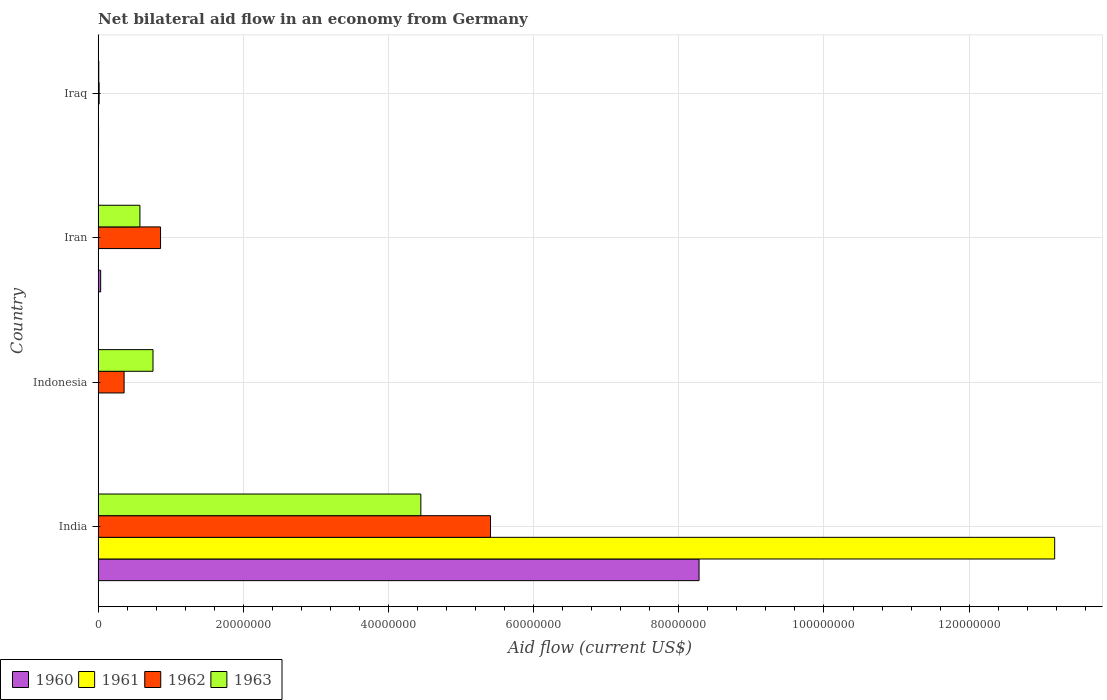How many bars are there on the 4th tick from the top?
Give a very brief answer. 4. How many bars are there on the 1st tick from the bottom?
Offer a very short reply. 4. In how many cases, is the number of bars for a given country not equal to the number of legend labels?
Your answer should be very brief. 1. Across all countries, what is the maximum net bilateral aid flow in 1963?
Your response must be concise. 4.45e+07. What is the total net bilateral aid flow in 1963 in the graph?
Your answer should be compact. 5.79e+07. What is the difference between the net bilateral aid flow in 1962 in Iran and that in Iraq?
Provide a succinct answer. 8.46e+06. What is the difference between the net bilateral aid flow in 1960 in India and the net bilateral aid flow in 1963 in Indonesia?
Give a very brief answer. 7.52e+07. What is the average net bilateral aid flow in 1963 per country?
Provide a succinct answer. 1.45e+07. What is the difference between the net bilateral aid flow in 1962 and net bilateral aid flow in 1960 in India?
Make the answer very short. -2.87e+07. What is the ratio of the net bilateral aid flow in 1963 in India to that in Indonesia?
Make the answer very short. 5.88. Is the net bilateral aid flow in 1962 in Indonesia less than that in Iraq?
Make the answer very short. No. Is the difference between the net bilateral aid flow in 1962 in Iran and Iraq greater than the difference between the net bilateral aid flow in 1960 in Iran and Iraq?
Your response must be concise. Yes. What is the difference between the highest and the second highest net bilateral aid flow in 1963?
Provide a short and direct response. 3.69e+07. What is the difference between the highest and the lowest net bilateral aid flow in 1960?
Make the answer very short. 8.28e+07. Is the sum of the net bilateral aid flow in 1960 in India and Iran greater than the maximum net bilateral aid flow in 1963 across all countries?
Give a very brief answer. Yes. Are all the bars in the graph horizontal?
Your answer should be compact. Yes. What is the difference between two consecutive major ticks on the X-axis?
Your answer should be compact. 2.00e+07. Does the graph contain grids?
Offer a terse response. Yes. Where does the legend appear in the graph?
Make the answer very short. Bottom left. How are the legend labels stacked?
Ensure brevity in your answer.  Horizontal. What is the title of the graph?
Your response must be concise. Net bilateral aid flow in an economy from Germany. Does "1966" appear as one of the legend labels in the graph?
Provide a succinct answer. No. What is the label or title of the Y-axis?
Ensure brevity in your answer.  Country. What is the Aid flow (current US$) of 1960 in India?
Ensure brevity in your answer.  8.28e+07. What is the Aid flow (current US$) of 1961 in India?
Offer a terse response. 1.32e+08. What is the Aid flow (current US$) in 1962 in India?
Provide a short and direct response. 5.41e+07. What is the Aid flow (current US$) of 1963 in India?
Give a very brief answer. 4.45e+07. What is the Aid flow (current US$) in 1960 in Indonesia?
Provide a succinct answer. 0. What is the Aid flow (current US$) in 1961 in Indonesia?
Provide a short and direct response. 0. What is the Aid flow (current US$) in 1962 in Indonesia?
Make the answer very short. 3.58e+06. What is the Aid flow (current US$) of 1963 in Indonesia?
Offer a very short reply. 7.56e+06. What is the Aid flow (current US$) of 1960 in Iran?
Keep it short and to the point. 3.50e+05. What is the Aid flow (current US$) in 1961 in Iran?
Make the answer very short. 3.00e+04. What is the Aid flow (current US$) of 1962 in Iran?
Provide a short and direct response. 8.60e+06. What is the Aid flow (current US$) of 1963 in Iran?
Ensure brevity in your answer.  5.76e+06. What is the Aid flow (current US$) in 1960 in Iraq?
Give a very brief answer. 6.00e+04. What is the Aid flow (current US$) of 1961 in Iraq?
Provide a succinct answer. 2.00e+04. What is the Aid flow (current US$) in 1962 in Iraq?
Your response must be concise. 1.40e+05. Across all countries, what is the maximum Aid flow (current US$) of 1960?
Give a very brief answer. 8.28e+07. Across all countries, what is the maximum Aid flow (current US$) of 1961?
Ensure brevity in your answer.  1.32e+08. Across all countries, what is the maximum Aid flow (current US$) in 1962?
Offer a very short reply. 5.41e+07. Across all countries, what is the maximum Aid flow (current US$) of 1963?
Your answer should be very brief. 4.45e+07. Across all countries, what is the minimum Aid flow (current US$) in 1960?
Make the answer very short. 0. Across all countries, what is the minimum Aid flow (current US$) in 1963?
Keep it short and to the point. 9.00e+04. What is the total Aid flow (current US$) in 1960 in the graph?
Provide a succinct answer. 8.32e+07. What is the total Aid flow (current US$) of 1961 in the graph?
Your answer should be compact. 1.32e+08. What is the total Aid flow (current US$) of 1962 in the graph?
Provide a succinct answer. 6.64e+07. What is the total Aid flow (current US$) in 1963 in the graph?
Provide a succinct answer. 5.79e+07. What is the difference between the Aid flow (current US$) of 1962 in India and that in Indonesia?
Your answer should be very brief. 5.05e+07. What is the difference between the Aid flow (current US$) of 1963 in India and that in Indonesia?
Provide a short and direct response. 3.69e+07. What is the difference between the Aid flow (current US$) of 1960 in India and that in Iran?
Give a very brief answer. 8.24e+07. What is the difference between the Aid flow (current US$) of 1961 in India and that in Iran?
Your answer should be very brief. 1.32e+08. What is the difference between the Aid flow (current US$) of 1962 in India and that in Iran?
Give a very brief answer. 4.55e+07. What is the difference between the Aid flow (current US$) in 1963 in India and that in Iran?
Ensure brevity in your answer.  3.87e+07. What is the difference between the Aid flow (current US$) of 1960 in India and that in Iraq?
Ensure brevity in your answer.  8.27e+07. What is the difference between the Aid flow (current US$) in 1961 in India and that in Iraq?
Your answer should be very brief. 1.32e+08. What is the difference between the Aid flow (current US$) of 1962 in India and that in Iraq?
Give a very brief answer. 5.39e+07. What is the difference between the Aid flow (current US$) of 1963 in India and that in Iraq?
Provide a succinct answer. 4.44e+07. What is the difference between the Aid flow (current US$) in 1962 in Indonesia and that in Iran?
Make the answer very short. -5.02e+06. What is the difference between the Aid flow (current US$) in 1963 in Indonesia and that in Iran?
Keep it short and to the point. 1.80e+06. What is the difference between the Aid flow (current US$) of 1962 in Indonesia and that in Iraq?
Provide a succinct answer. 3.44e+06. What is the difference between the Aid flow (current US$) of 1963 in Indonesia and that in Iraq?
Your response must be concise. 7.47e+06. What is the difference between the Aid flow (current US$) in 1961 in Iran and that in Iraq?
Offer a very short reply. 10000. What is the difference between the Aid flow (current US$) in 1962 in Iran and that in Iraq?
Ensure brevity in your answer.  8.46e+06. What is the difference between the Aid flow (current US$) of 1963 in Iran and that in Iraq?
Provide a succinct answer. 5.67e+06. What is the difference between the Aid flow (current US$) in 1960 in India and the Aid flow (current US$) in 1962 in Indonesia?
Offer a terse response. 7.92e+07. What is the difference between the Aid flow (current US$) in 1960 in India and the Aid flow (current US$) in 1963 in Indonesia?
Make the answer very short. 7.52e+07. What is the difference between the Aid flow (current US$) of 1961 in India and the Aid flow (current US$) of 1962 in Indonesia?
Your answer should be compact. 1.28e+08. What is the difference between the Aid flow (current US$) of 1961 in India and the Aid flow (current US$) of 1963 in Indonesia?
Your answer should be compact. 1.24e+08. What is the difference between the Aid flow (current US$) of 1962 in India and the Aid flow (current US$) of 1963 in Indonesia?
Offer a terse response. 4.65e+07. What is the difference between the Aid flow (current US$) of 1960 in India and the Aid flow (current US$) of 1961 in Iran?
Provide a succinct answer. 8.28e+07. What is the difference between the Aid flow (current US$) of 1960 in India and the Aid flow (current US$) of 1962 in Iran?
Your answer should be compact. 7.42e+07. What is the difference between the Aid flow (current US$) of 1960 in India and the Aid flow (current US$) of 1963 in Iran?
Provide a short and direct response. 7.70e+07. What is the difference between the Aid flow (current US$) of 1961 in India and the Aid flow (current US$) of 1962 in Iran?
Offer a terse response. 1.23e+08. What is the difference between the Aid flow (current US$) of 1961 in India and the Aid flow (current US$) of 1963 in Iran?
Provide a succinct answer. 1.26e+08. What is the difference between the Aid flow (current US$) of 1962 in India and the Aid flow (current US$) of 1963 in Iran?
Offer a terse response. 4.83e+07. What is the difference between the Aid flow (current US$) in 1960 in India and the Aid flow (current US$) in 1961 in Iraq?
Your answer should be compact. 8.28e+07. What is the difference between the Aid flow (current US$) in 1960 in India and the Aid flow (current US$) in 1962 in Iraq?
Give a very brief answer. 8.26e+07. What is the difference between the Aid flow (current US$) in 1960 in India and the Aid flow (current US$) in 1963 in Iraq?
Offer a terse response. 8.27e+07. What is the difference between the Aid flow (current US$) of 1961 in India and the Aid flow (current US$) of 1962 in Iraq?
Give a very brief answer. 1.32e+08. What is the difference between the Aid flow (current US$) in 1961 in India and the Aid flow (current US$) in 1963 in Iraq?
Make the answer very short. 1.32e+08. What is the difference between the Aid flow (current US$) of 1962 in India and the Aid flow (current US$) of 1963 in Iraq?
Keep it short and to the point. 5.40e+07. What is the difference between the Aid flow (current US$) in 1962 in Indonesia and the Aid flow (current US$) in 1963 in Iran?
Offer a terse response. -2.18e+06. What is the difference between the Aid flow (current US$) in 1962 in Indonesia and the Aid flow (current US$) in 1963 in Iraq?
Ensure brevity in your answer.  3.49e+06. What is the difference between the Aid flow (current US$) of 1960 in Iran and the Aid flow (current US$) of 1961 in Iraq?
Provide a succinct answer. 3.30e+05. What is the difference between the Aid flow (current US$) in 1960 in Iran and the Aid flow (current US$) in 1962 in Iraq?
Your answer should be compact. 2.10e+05. What is the difference between the Aid flow (current US$) of 1960 in Iran and the Aid flow (current US$) of 1963 in Iraq?
Make the answer very short. 2.60e+05. What is the difference between the Aid flow (current US$) of 1961 in Iran and the Aid flow (current US$) of 1962 in Iraq?
Your response must be concise. -1.10e+05. What is the difference between the Aid flow (current US$) of 1961 in Iran and the Aid flow (current US$) of 1963 in Iraq?
Ensure brevity in your answer.  -6.00e+04. What is the difference between the Aid flow (current US$) of 1962 in Iran and the Aid flow (current US$) of 1963 in Iraq?
Your answer should be very brief. 8.51e+06. What is the average Aid flow (current US$) in 1960 per country?
Make the answer very short. 2.08e+07. What is the average Aid flow (current US$) of 1961 per country?
Offer a terse response. 3.30e+07. What is the average Aid flow (current US$) of 1962 per country?
Provide a short and direct response. 1.66e+07. What is the average Aid flow (current US$) of 1963 per country?
Offer a very short reply. 1.45e+07. What is the difference between the Aid flow (current US$) in 1960 and Aid flow (current US$) in 1961 in India?
Your answer should be very brief. -4.90e+07. What is the difference between the Aid flow (current US$) in 1960 and Aid flow (current US$) in 1962 in India?
Give a very brief answer. 2.87e+07. What is the difference between the Aid flow (current US$) in 1960 and Aid flow (current US$) in 1963 in India?
Give a very brief answer. 3.83e+07. What is the difference between the Aid flow (current US$) in 1961 and Aid flow (current US$) in 1962 in India?
Offer a terse response. 7.77e+07. What is the difference between the Aid flow (current US$) of 1961 and Aid flow (current US$) of 1963 in India?
Keep it short and to the point. 8.73e+07. What is the difference between the Aid flow (current US$) of 1962 and Aid flow (current US$) of 1963 in India?
Your answer should be compact. 9.60e+06. What is the difference between the Aid flow (current US$) in 1962 and Aid flow (current US$) in 1963 in Indonesia?
Make the answer very short. -3.98e+06. What is the difference between the Aid flow (current US$) in 1960 and Aid flow (current US$) in 1961 in Iran?
Ensure brevity in your answer.  3.20e+05. What is the difference between the Aid flow (current US$) in 1960 and Aid flow (current US$) in 1962 in Iran?
Provide a succinct answer. -8.25e+06. What is the difference between the Aid flow (current US$) in 1960 and Aid flow (current US$) in 1963 in Iran?
Keep it short and to the point. -5.41e+06. What is the difference between the Aid flow (current US$) in 1961 and Aid flow (current US$) in 1962 in Iran?
Offer a terse response. -8.57e+06. What is the difference between the Aid flow (current US$) of 1961 and Aid flow (current US$) of 1963 in Iran?
Offer a very short reply. -5.73e+06. What is the difference between the Aid flow (current US$) in 1962 and Aid flow (current US$) in 1963 in Iran?
Offer a very short reply. 2.84e+06. What is the difference between the Aid flow (current US$) of 1960 and Aid flow (current US$) of 1962 in Iraq?
Keep it short and to the point. -8.00e+04. What is the ratio of the Aid flow (current US$) of 1962 in India to that in Indonesia?
Provide a short and direct response. 15.1. What is the ratio of the Aid flow (current US$) of 1963 in India to that in Indonesia?
Provide a succinct answer. 5.88. What is the ratio of the Aid flow (current US$) of 1960 in India to that in Iran?
Give a very brief answer. 236.54. What is the ratio of the Aid flow (current US$) in 1961 in India to that in Iran?
Provide a succinct answer. 4392.67. What is the ratio of the Aid flow (current US$) in 1962 in India to that in Iran?
Provide a short and direct response. 6.29. What is the ratio of the Aid flow (current US$) in 1963 in India to that in Iran?
Provide a short and direct response. 7.72. What is the ratio of the Aid flow (current US$) in 1960 in India to that in Iraq?
Give a very brief answer. 1379.83. What is the ratio of the Aid flow (current US$) in 1961 in India to that in Iraq?
Provide a succinct answer. 6589. What is the ratio of the Aid flow (current US$) of 1962 in India to that in Iraq?
Ensure brevity in your answer.  386.14. What is the ratio of the Aid flow (current US$) in 1963 in India to that in Iraq?
Your response must be concise. 494. What is the ratio of the Aid flow (current US$) of 1962 in Indonesia to that in Iran?
Your answer should be very brief. 0.42. What is the ratio of the Aid flow (current US$) of 1963 in Indonesia to that in Iran?
Offer a very short reply. 1.31. What is the ratio of the Aid flow (current US$) in 1962 in Indonesia to that in Iraq?
Offer a terse response. 25.57. What is the ratio of the Aid flow (current US$) in 1960 in Iran to that in Iraq?
Give a very brief answer. 5.83. What is the ratio of the Aid flow (current US$) in 1961 in Iran to that in Iraq?
Provide a short and direct response. 1.5. What is the ratio of the Aid flow (current US$) in 1962 in Iran to that in Iraq?
Keep it short and to the point. 61.43. What is the ratio of the Aid flow (current US$) of 1963 in Iran to that in Iraq?
Offer a terse response. 64. What is the difference between the highest and the second highest Aid flow (current US$) in 1960?
Your answer should be very brief. 8.24e+07. What is the difference between the highest and the second highest Aid flow (current US$) in 1961?
Your response must be concise. 1.32e+08. What is the difference between the highest and the second highest Aid flow (current US$) of 1962?
Ensure brevity in your answer.  4.55e+07. What is the difference between the highest and the second highest Aid flow (current US$) of 1963?
Give a very brief answer. 3.69e+07. What is the difference between the highest and the lowest Aid flow (current US$) in 1960?
Ensure brevity in your answer.  8.28e+07. What is the difference between the highest and the lowest Aid flow (current US$) of 1961?
Offer a very short reply. 1.32e+08. What is the difference between the highest and the lowest Aid flow (current US$) of 1962?
Ensure brevity in your answer.  5.39e+07. What is the difference between the highest and the lowest Aid flow (current US$) of 1963?
Provide a succinct answer. 4.44e+07. 